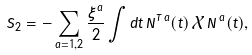Convert formula to latex. <formula><loc_0><loc_0><loc_500><loc_500>S _ { 2 } = - \sum _ { a = 1 , 2 } \frac { \xi ^ { a } } { 2 } \int d t \, { N } ^ { { T } \, a } ( t ) \, \hat { \mathcal { X } } \, { N } ^ { \, a } ( t ) ,</formula> 